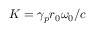Convert formula to latex. <formula><loc_0><loc_0><loc_500><loc_500>K = \gamma _ { p } r _ { 0 } \omega _ { 0 } / c</formula> 